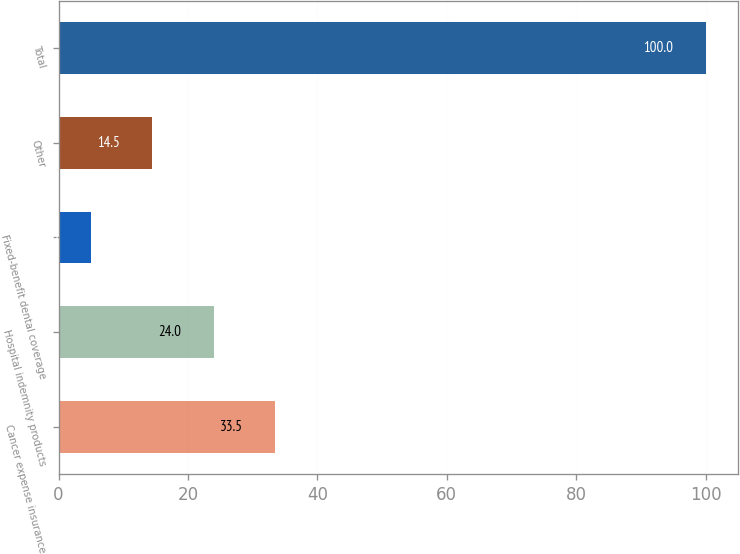Convert chart to OTSL. <chart><loc_0><loc_0><loc_500><loc_500><bar_chart><fcel>Cancer expense insurance<fcel>Hospital indemnity products<fcel>Fixed-benefit dental coverage<fcel>Other<fcel>Total<nl><fcel>33.5<fcel>24<fcel>5<fcel>14.5<fcel>100<nl></chart> 